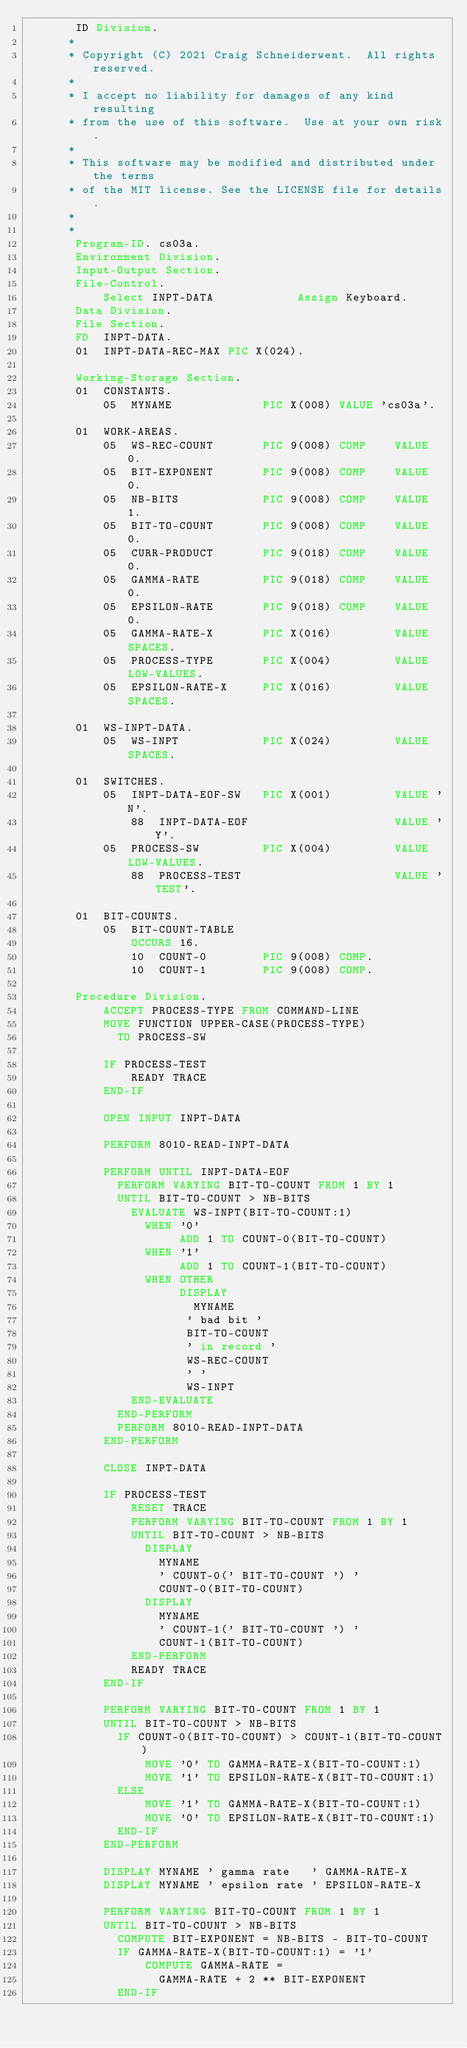<code> <loc_0><loc_0><loc_500><loc_500><_COBOL_>       ID Division.
      * 
      * Copyright (C) 2021 Craig Schneiderwent.  All rights reserved.
      * 
      * I accept no liability for damages of any kind resulting 
      * from the use of this software.  Use at your own risk.
      *
      * This software may be modified and distributed under the terms
      * of the MIT license. See the LICENSE file for details.
      *
      *
       Program-ID. cs03a.
       Environment Division.
       Input-Output Section.
       File-Control.
           Select INPT-DATA            Assign Keyboard.
       Data Division.
       File Section.
       FD  INPT-DATA.
       01  INPT-DATA-REC-MAX PIC X(024).

       Working-Storage Section.
       01  CONSTANTS.
           05  MYNAME             PIC X(008) VALUE 'cs03a'.

       01  WORK-AREAS.
           05  WS-REC-COUNT       PIC 9(008) COMP    VALUE 0.
           05  BIT-EXPONENT       PIC 9(008) COMP    VALUE 0.
           05  NB-BITS            PIC 9(008) COMP    VALUE 1.
           05  BIT-TO-COUNT       PIC 9(008) COMP    VALUE 0.
           05  CURR-PRODUCT       PIC 9(018) COMP    VALUE 0.
           05  GAMMA-RATE         PIC 9(018) COMP    VALUE 0.
           05  EPSILON-RATE       PIC 9(018) COMP    VALUE 0.
           05  GAMMA-RATE-X       PIC X(016)         VALUE SPACES.
           05  PROCESS-TYPE       PIC X(004)         VALUE LOW-VALUES.
           05  EPSILON-RATE-X     PIC X(016)         VALUE SPACES.

       01  WS-INPT-DATA.
           05  WS-INPT            PIC X(024)         VALUE SPACES.

       01  SWITCHES.
           05  INPT-DATA-EOF-SW   PIC X(001)         VALUE 'N'.
               88  INPT-DATA-EOF                     VALUE 'Y'.
           05  PROCESS-SW         PIC X(004)         VALUE LOW-VALUES.
               88  PROCESS-TEST                      VALUE 'TEST'.

       01  BIT-COUNTS.
           05  BIT-COUNT-TABLE
               OCCURS 16.
               10  COUNT-0        PIC 9(008) COMP.
               10  COUNT-1        PIC 9(008) COMP.

       Procedure Division.
           ACCEPT PROCESS-TYPE FROM COMMAND-LINE
           MOVE FUNCTION UPPER-CASE(PROCESS-TYPE)
             TO PROCESS-SW

           IF PROCESS-TEST
               READY TRACE
           END-IF

           OPEN INPUT INPT-DATA

           PERFORM 8010-READ-INPT-DATA

           PERFORM UNTIL INPT-DATA-EOF
             PERFORM VARYING BIT-TO-COUNT FROM 1 BY 1
             UNTIL BIT-TO-COUNT > NB-BITS
               EVALUATE WS-INPT(BIT-TO-COUNT:1)
                 WHEN '0'
                      ADD 1 TO COUNT-0(BIT-TO-COUNT)
                 WHEN '1'
                      ADD 1 TO COUNT-1(BIT-TO-COUNT)
                 WHEN OTHER
                      DISPLAY
                        MYNAME
                       ' bad bit '
                       BIT-TO-COUNT
                       ' in record '
                       WS-REC-COUNT
                       ' '
                       WS-INPT 
               END-EVALUATE
             END-PERFORM
             PERFORM 8010-READ-INPT-DATA
           END-PERFORM

           CLOSE INPT-DATA

           IF PROCESS-TEST
               RESET TRACE
               PERFORM VARYING BIT-TO-COUNT FROM 1 BY 1
               UNTIL BIT-TO-COUNT > NB-BITS
                 DISPLAY
                   MYNAME
                   ' COUNT-0(' BIT-TO-COUNT ') '
                   COUNT-0(BIT-TO-COUNT)
                 DISPLAY
                   MYNAME
                   ' COUNT-1(' BIT-TO-COUNT ') '
                   COUNT-1(BIT-TO-COUNT)
               END-PERFORM
               READY TRACE
           END-IF

           PERFORM VARYING BIT-TO-COUNT FROM 1 BY 1
           UNTIL BIT-TO-COUNT > NB-BITS
             IF COUNT-0(BIT-TO-COUNT) > COUNT-1(BIT-TO-COUNT)
                 MOVE '0' TO GAMMA-RATE-X(BIT-TO-COUNT:1)
                 MOVE '1' TO EPSILON-RATE-X(BIT-TO-COUNT:1)
             ELSE
                 MOVE '1' TO GAMMA-RATE-X(BIT-TO-COUNT:1)
                 MOVE '0' TO EPSILON-RATE-X(BIT-TO-COUNT:1)
             END-IF
           END-PERFORM

           DISPLAY MYNAME ' gamma rate   ' GAMMA-RATE-X
           DISPLAY MYNAME ' epsilon rate ' EPSILON-RATE-X

           PERFORM VARYING BIT-TO-COUNT FROM 1 BY 1
           UNTIL BIT-TO-COUNT > NB-BITS
             COMPUTE BIT-EXPONENT = NB-BITS - BIT-TO-COUNT
             IF GAMMA-RATE-X(BIT-TO-COUNT:1) = '1'
                 COMPUTE GAMMA-RATE =
                   GAMMA-RATE + 2 ** BIT-EXPONENT
             END-IF</code> 